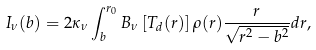<formula> <loc_0><loc_0><loc_500><loc_500>I _ { \nu } ( b ) = 2 \kappa _ { \nu } \int ^ { r _ { 0 } } _ { b } B _ { \nu } \left [ T _ { d } ( r ) \right ] \rho ( r ) \frac { r } { \sqrt { r ^ { 2 } - b ^ { 2 } } } d r ,</formula> 